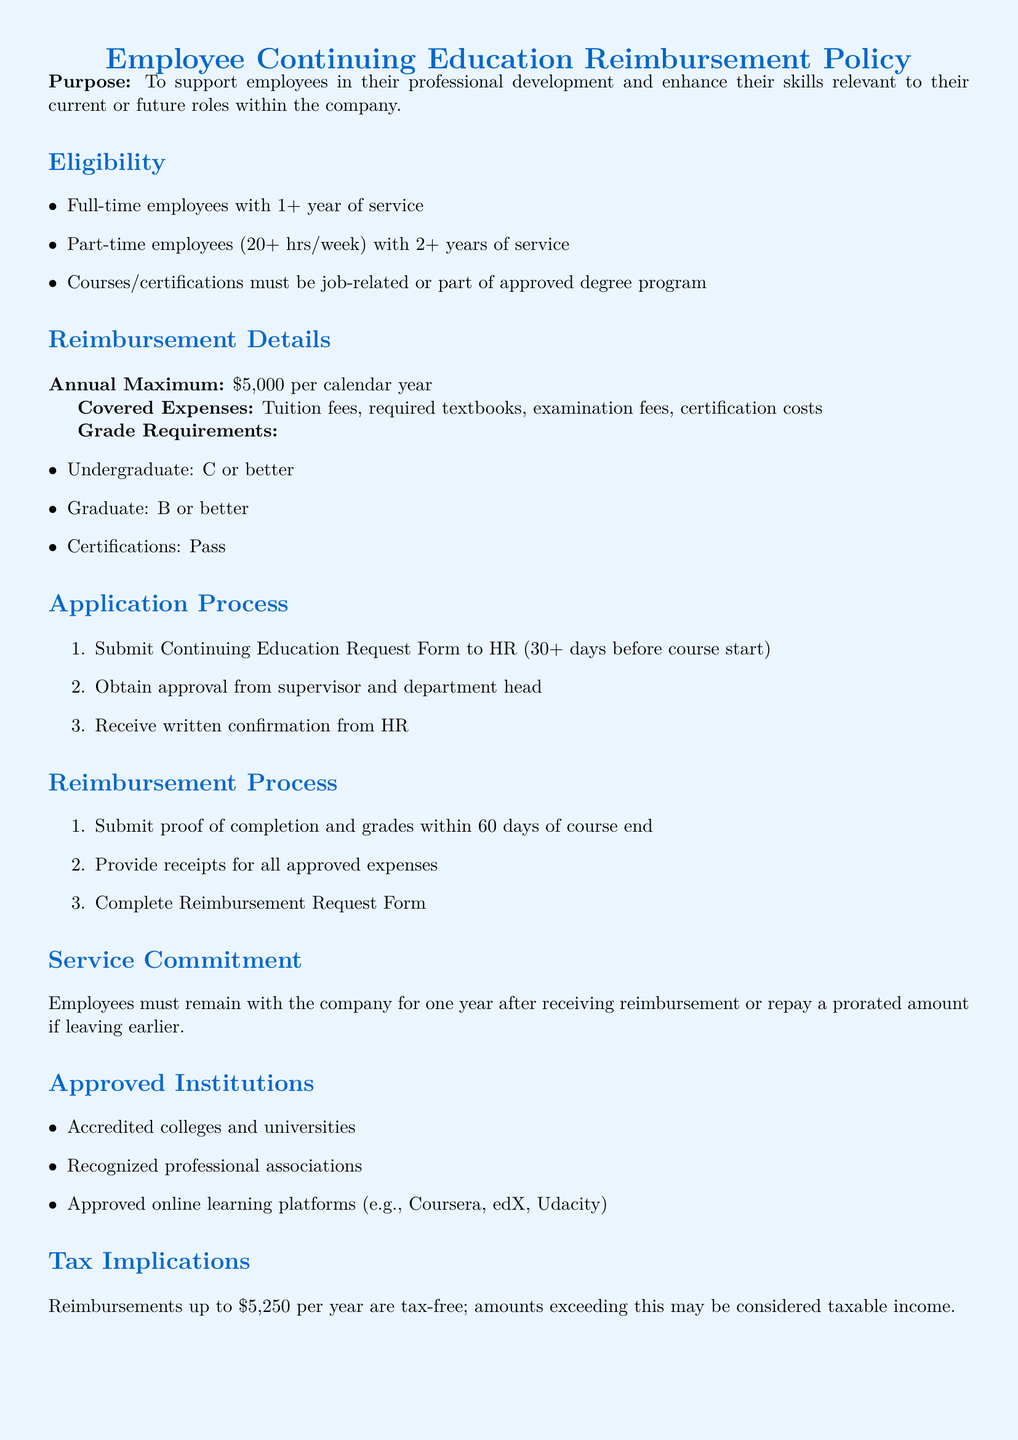What is the purpose of the policy? The purpose of the policy is to support employees in their professional development and enhance their skills relevant to their current or future roles within the company.
Answer: Support employees in their professional development Who is eligible for the reimbursement? Eligibility is based on full-time employees with 1+ year of service or part-time employees with 2+ years of service, and the courses must be job-related.
Answer: Full-time and part-time employees What is the maximum reimbursement amount per year? The document states that the annual maximum reimbursement amount is $5,000 for each calendar year.
Answer: $5,000 What is the grade requirement for undergraduate courses? The grade requirement mentioned in the document for undergraduate courses is a C or better.
Answer: C or better What must employees submit to HR before taking a course? Employees must submit a Continuing Education Request Form to HR at least 30 days before the course start.
Answer: Continuing Education Request Form For how long must employees remain with the company after receiving reimbursement? Employees must remain with the company for one year after receiving reimbursement or repay a prorated amount if leaving earlier.
Answer: One year What types of institutions are approved for reimbursement? The policy specifies that accredited colleges and universities, recognized professional associations, and approved online learning platforms are included.
Answer: Accredited colleges and universities What is the tax implication for reimbursements up to $5,250? The document states that reimbursements up to $5,250 per year are tax-free.
Answer: Tax-free 